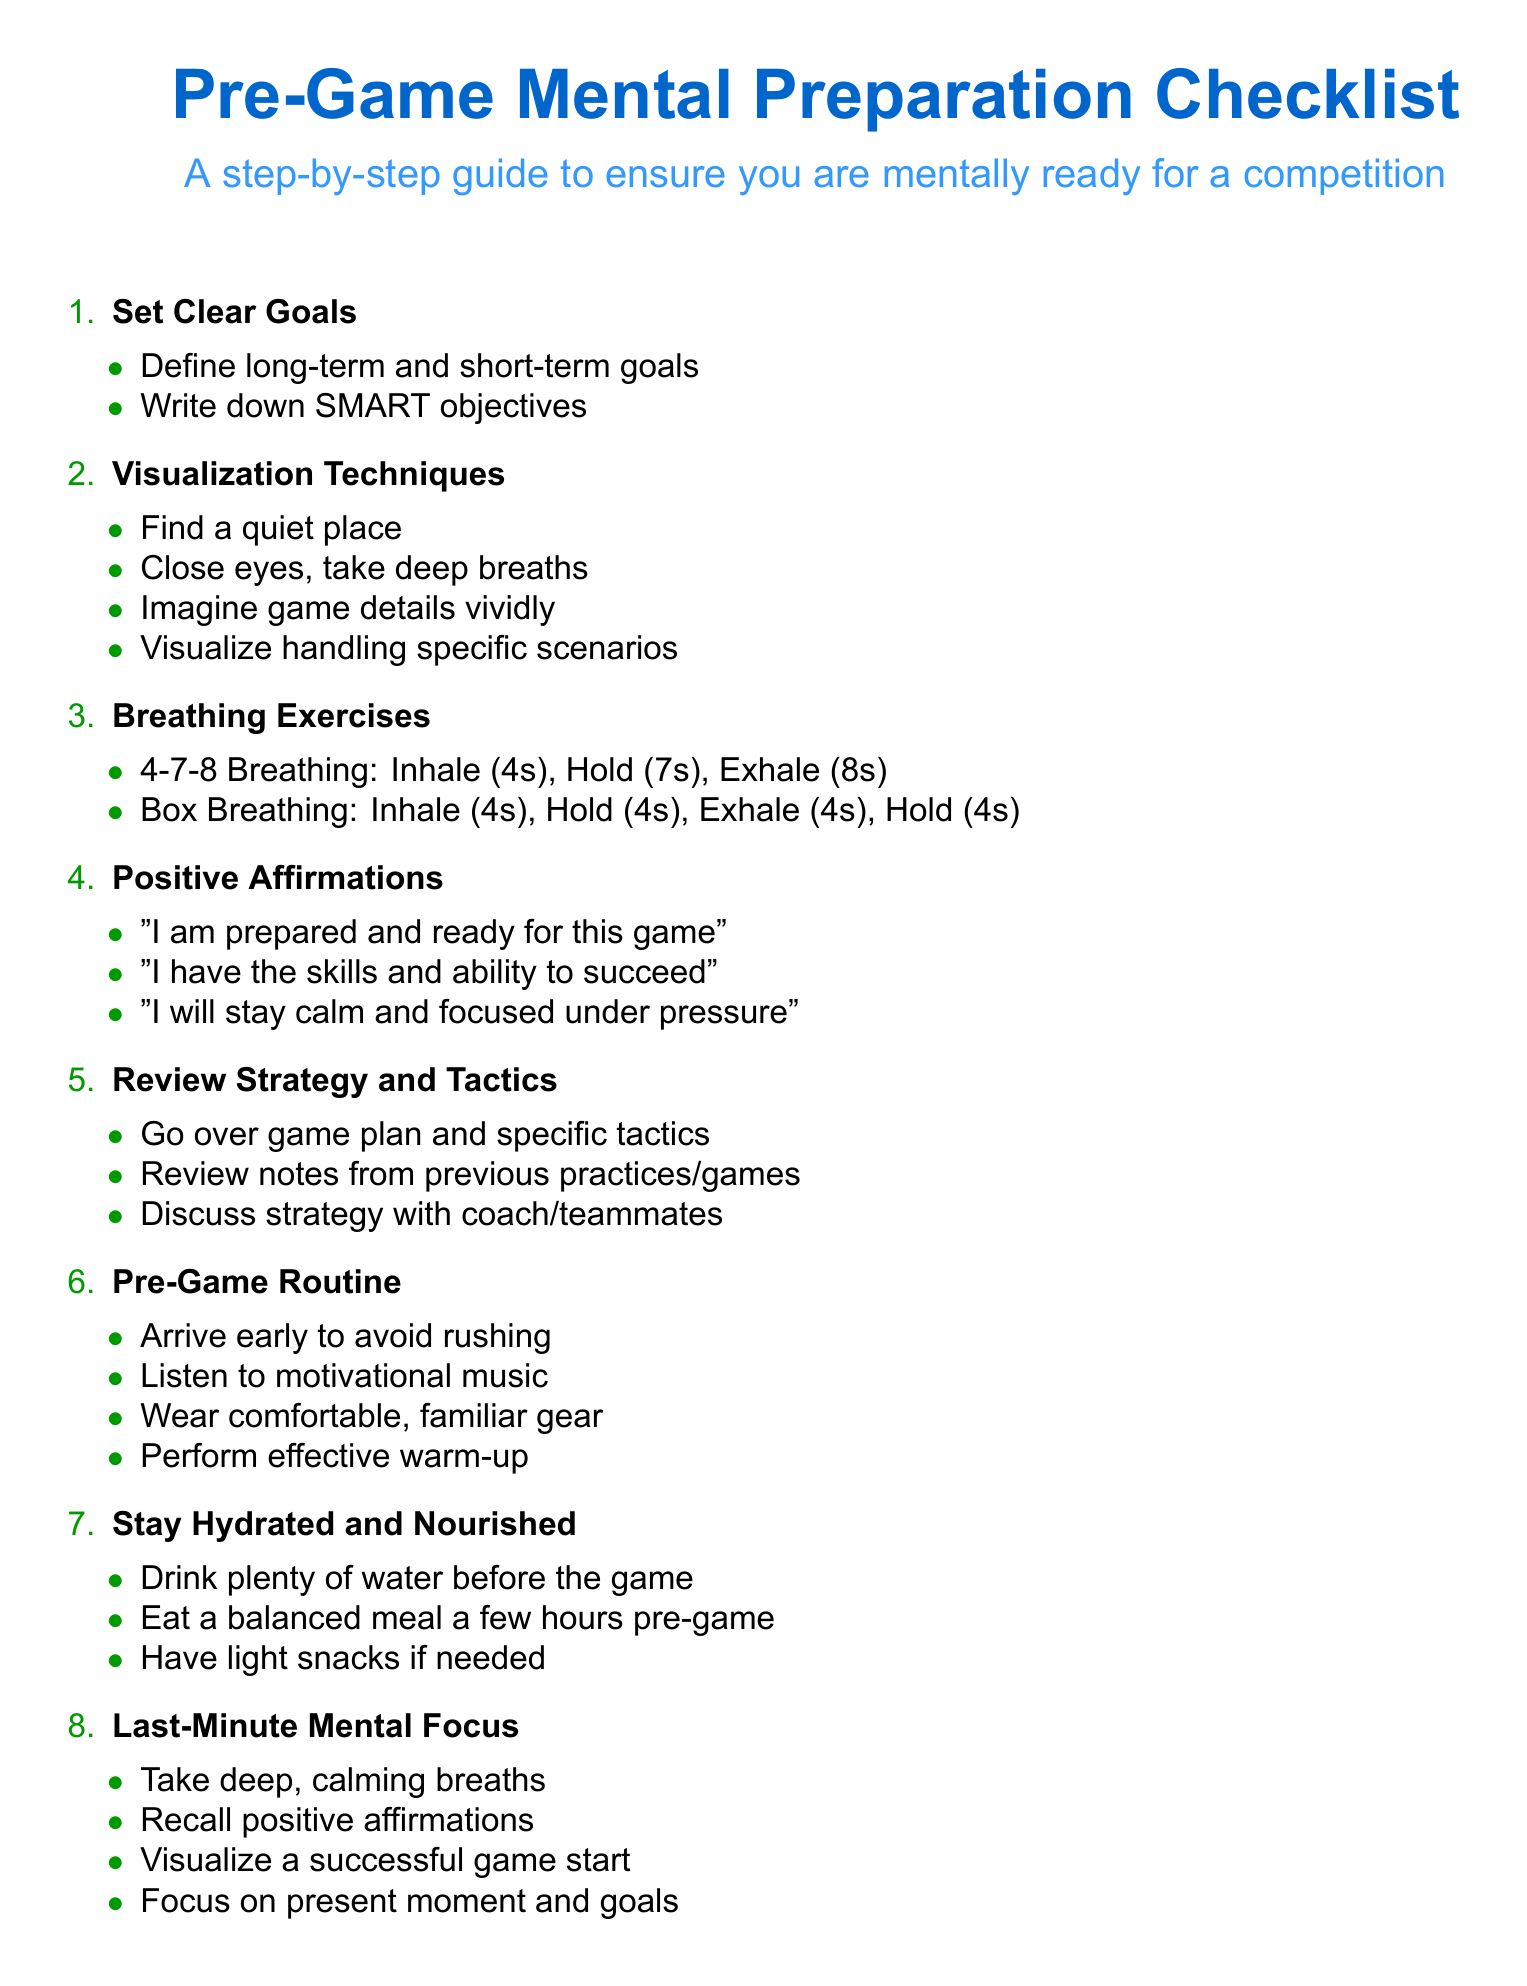What are the two types of breathing exercises mentioned? The breathing exercises listed are "4-7-8 Breathing" and "Box Breathing".
Answer: 4-7-8 Breathing, Box Breathing How many steps are included in the checklist? The checklist consists of a total of 8 steps listed numerically.
Answer: 8 What type of affirmations should you use? The document advises using "Positive Affirmations" as a mental preparation technique.
Answer: Positive Affirmations What should you do just before the game according to the last step? The last step emphasizes the importance of focusing on mental readiness just before the game through various techniques.
Answer: Last-Minute Mental Focus What action should be taken regarding hydration before the game? Staying hydrated before the game entails drinking plenty of water, as stated in the checklist.
Answer: Drink plenty of water 